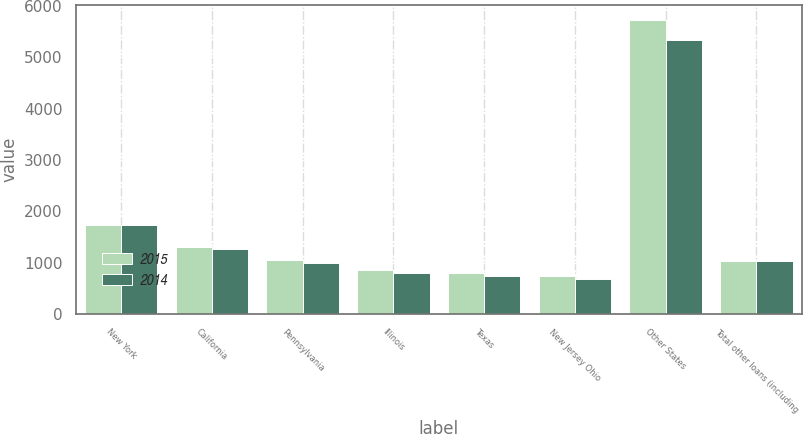<chart> <loc_0><loc_0><loc_500><loc_500><stacked_bar_chart><ecel><fcel>New York<fcel>California<fcel>Pennsylvania<fcel>Illinois<fcel>Texas<fcel>New Jersey Ohio<fcel>Other States<fcel>Total other loans (including<nl><fcel>2015<fcel>1743<fcel>1312<fcel>1059<fcel>865<fcel>804<fcel>737<fcel>5724<fcel>1031.5<nl><fcel>2014<fcel>1738<fcel>1267<fcel>1004<fcel>794<fcel>742<fcel>687<fcel>5347<fcel>1031.5<nl></chart> 